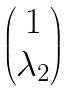Convert formula to latex. <formula><loc_0><loc_0><loc_500><loc_500>\begin{pmatrix} 1 \\ \lambda _ { 2 } \end{pmatrix}</formula> 